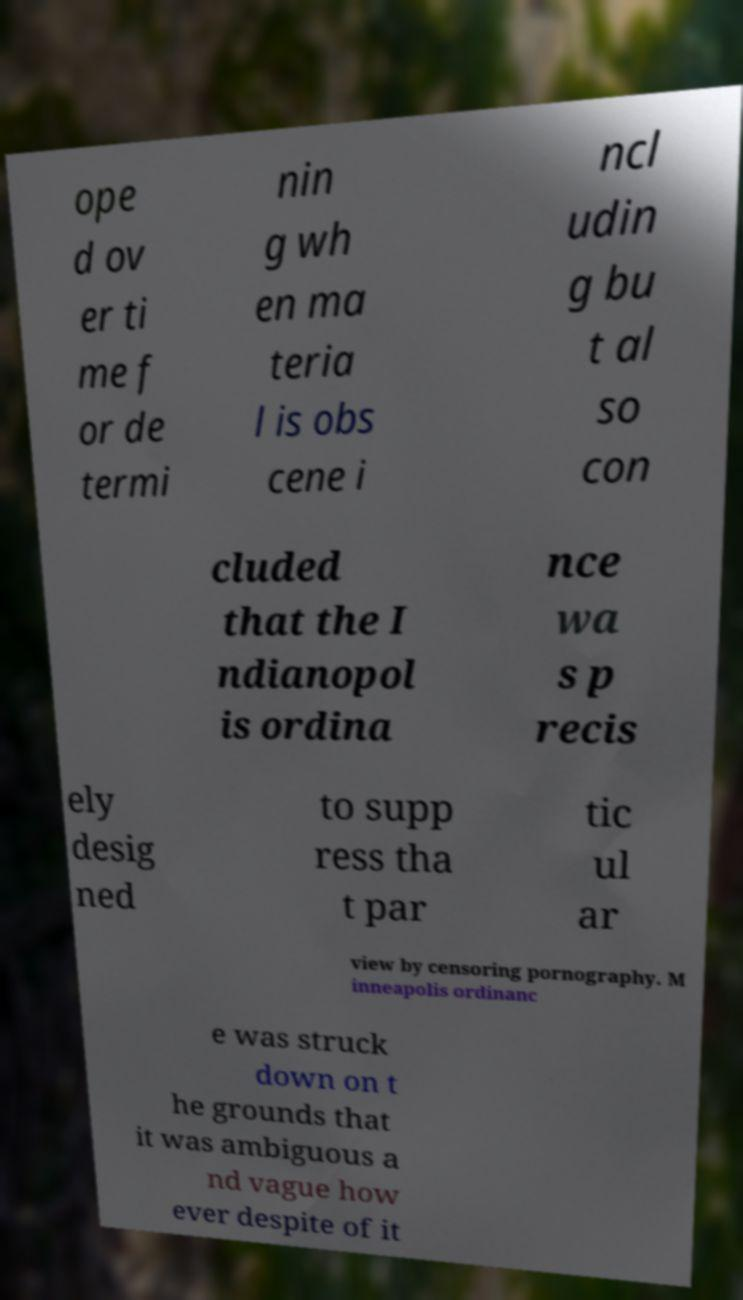Can you read and provide the text displayed in the image?This photo seems to have some interesting text. Can you extract and type it out for me? ope d ov er ti me f or de termi nin g wh en ma teria l is obs cene i ncl udin g bu t al so con cluded that the I ndianopol is ordina nce wa s p recis ely desig ned to supp ress tha t par tic ul ar view by censoring pornography. M inneapolis ordinanc e was struck down on t he grounds that it was ambiguous a nd vague how ever despite of it 